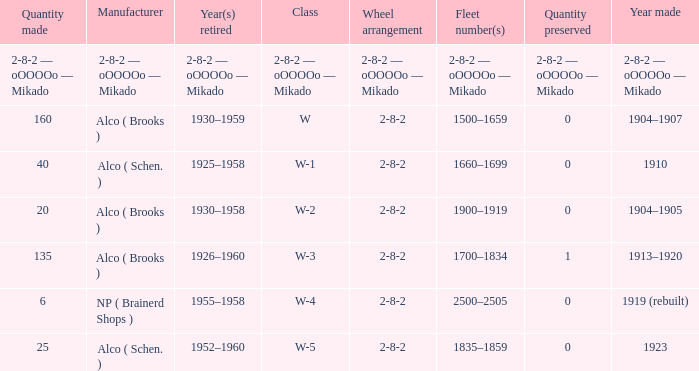Could you parse the entire table? {'header': ['Quantity made', 'Manufacturer', 'Year(s) retired', 'Class', 'Wheel arrangement', 'Fleet number(s)', 'Quantity preserved', 'Year made'], 'rows': [['2-8-2 — oOOOOo — Mikado', '2-8-2 — oOOOOo — Mikado', '2-8-2 — oOOOOo — Mikado', '2-8-2 — oOOOOo — Mikado', '2-8-2 — oOOOOo — Mikado', '2-8-2 — oOOOOo — Mikado', '2-8-2 — oOOOOo — Mikado', '2-8-2 — oOOOOo — Mikado'], ['160', 'Alco ( Brooks )', '1930–1959', 'W', '2-8-2', '1500–1659', '0', '1904–1907'], ['40', 'Alco ( Schen. )', '1925–1958', 'W-1', '2-8-2', '1660–1699', '0', '1910'], ['20', 'Alco ( Brooks )', '1930–1958', 'W-2', '2-8-2', '1900–1919', '0', '1904–1905'], ['135', 'Alco ( Brooks )', '1926–1960', 'W-3', '2-8-2', '1700–1834', '1', '1913–1920'], ['6', 'NP ( Brainerd Shops )', '1955–1958', 'W-4', '2-8-2', '2500–2505', '0', '1919 (rebuilt)'], ['25', 'Alco ( Schen. )', '1952–1960', 'W-5', '2-8-2', '1835–1859', '0', '1923']]} What is the year retired of the locomotive which had the quantity made of 25? 1952–1960. 